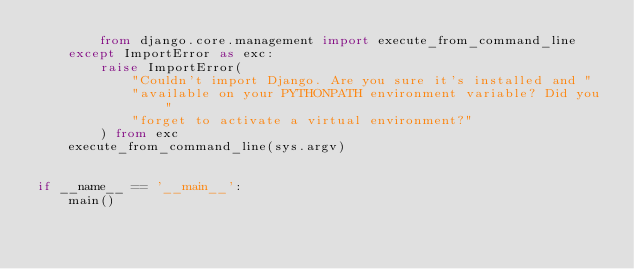<code> <loc_0><loc_0><loc_500><loc_500><_Python_>        from django.core.management import execute_from_command_line
    except ImportError as exc:
        raise ImportError(
            "Couldn't import Django. Are you sure it's installed and "
            "available on your PYTHONPATH environment variable? Did you "
            "forget to activate a virtual environment?"
        ) from exc
    execute_from_command_line(sys.argv)


if __name__ == '__main__':
    main()
</code> 